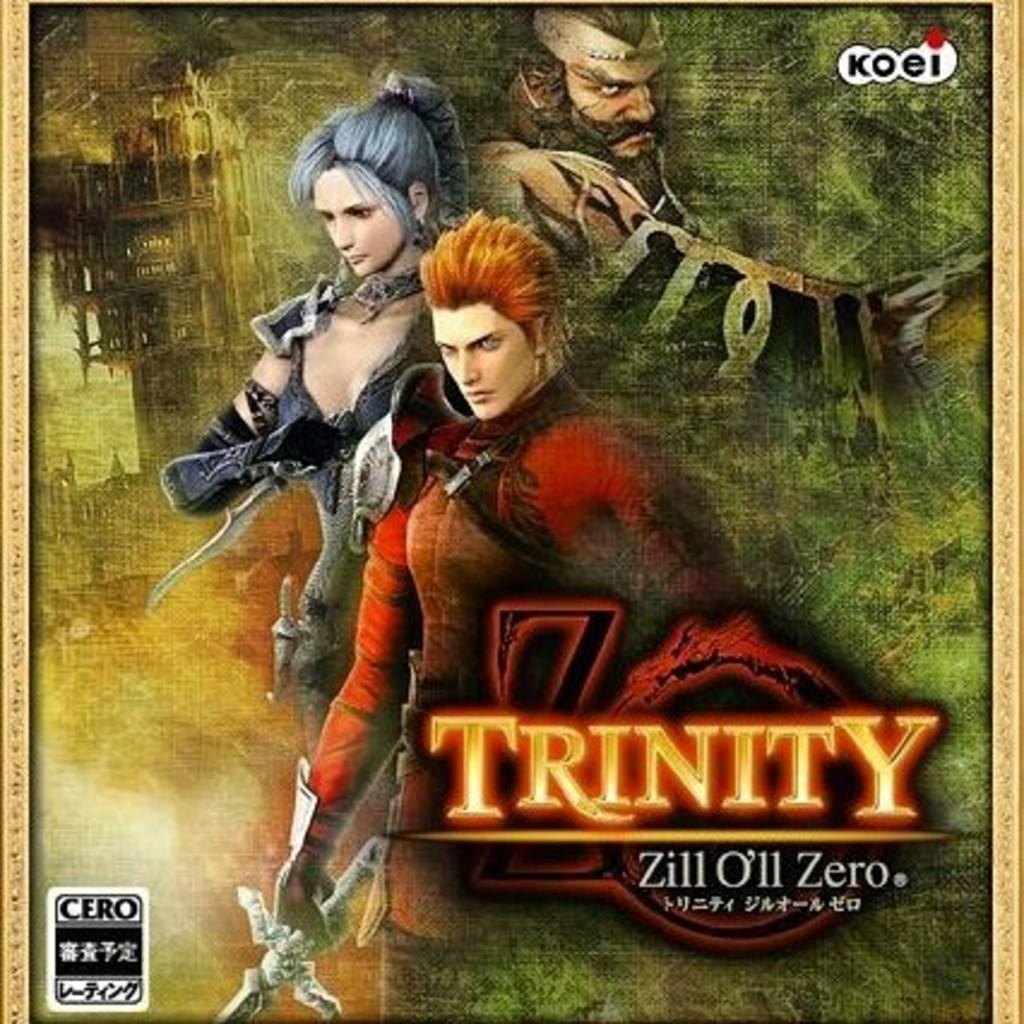What is featured in the image? There is a poster in the image. What type of images are on the poster? The poster contains animated images. Are there any words on the poster? Yes, the poster contains text. Can you describe the logos in the image? There is a logo in the top right corner and another in the bottom left corner of the image. What idea does the brother have about the harbor in the image? There is no brother or harbor mentioned in the image; it only features a poster with animated images, text, and logos. 